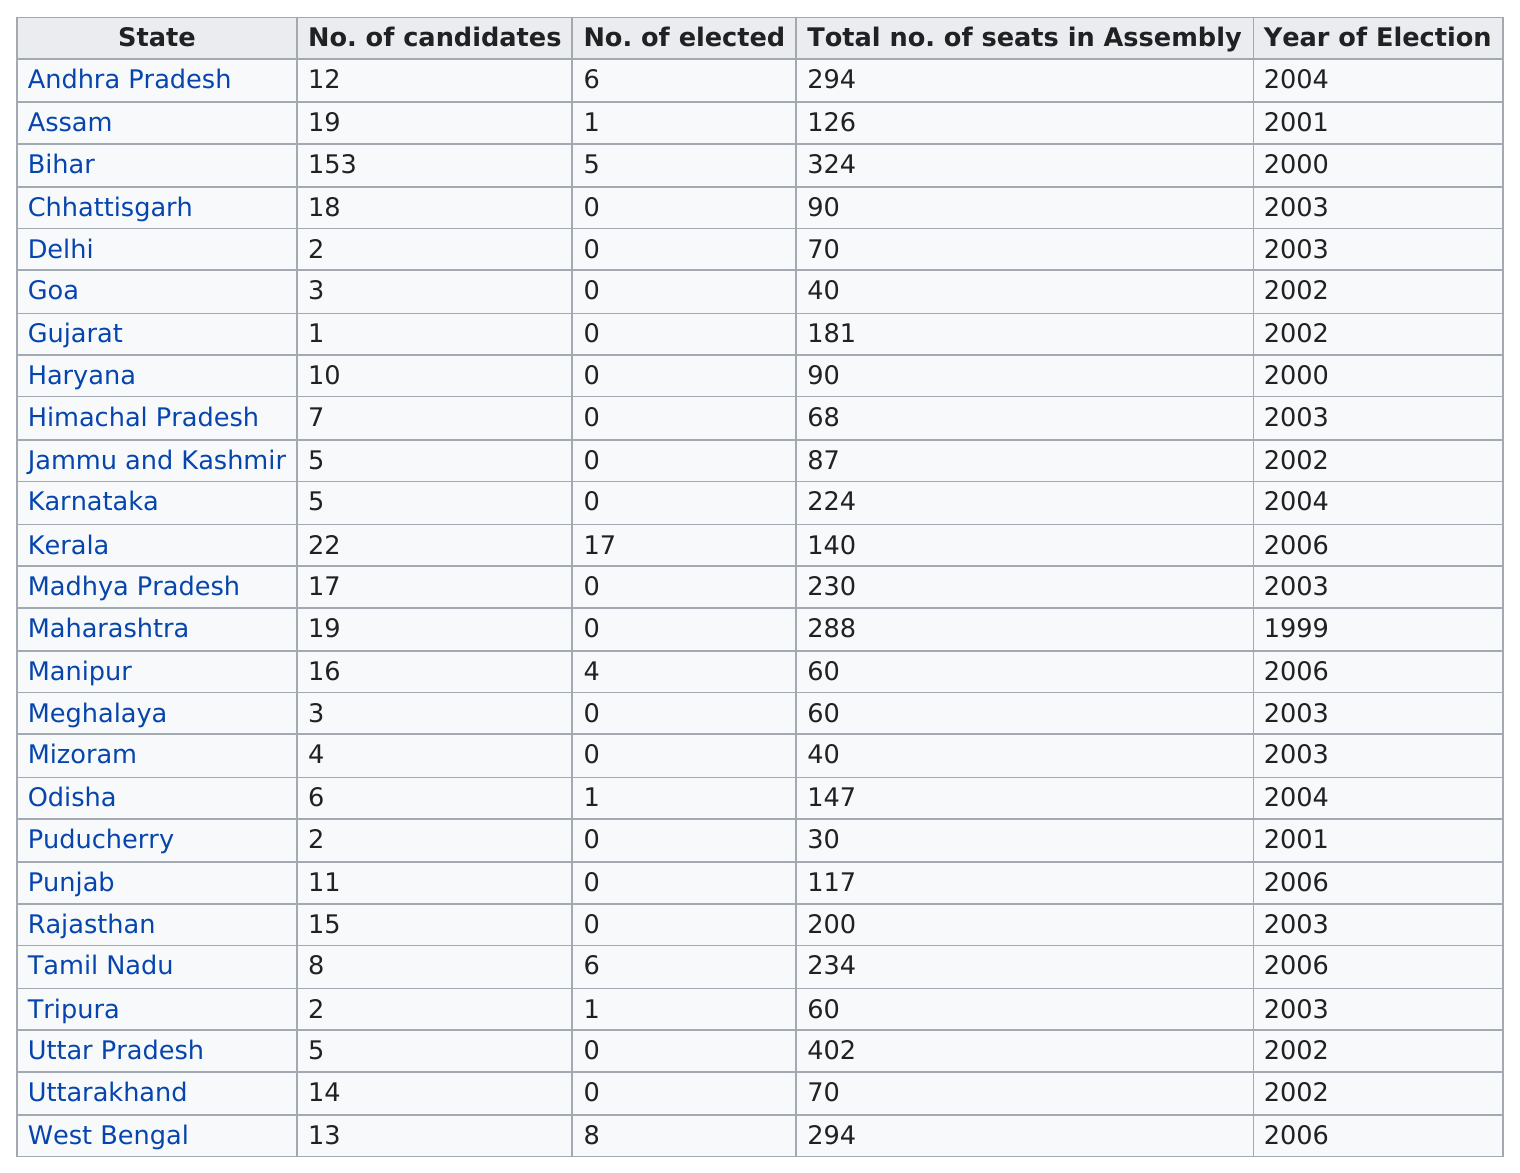Mention a couple of crucial points in this snapshot. The top state in the table is Andhra Pradesh. Goa had 3 candidates in the 2021 assembly election, and Meghalaya had 3 candidates as well. Delhi is the first state after Goa. The elected representative is from Kerala, who was elected by the people of Kerala. A total of 17 candidates were elected in Kerala. 